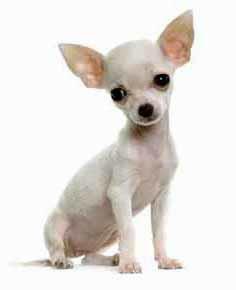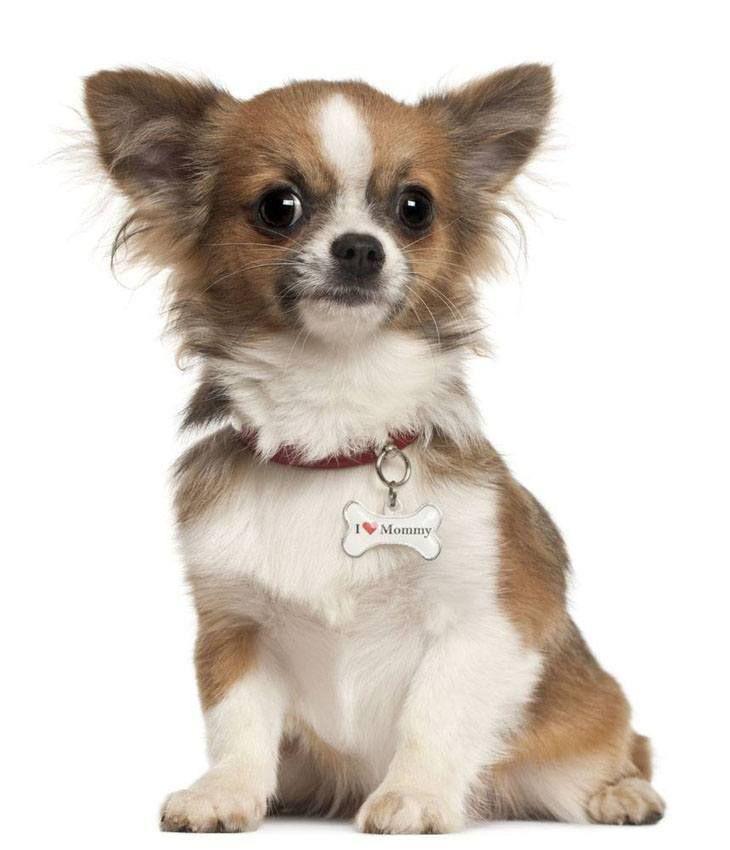The first image is the image on the left, the second image is the image on the right. For the images shown, is this caption "Of the two dogs shown, one dog's ears are floppy or folded, and the other dog's ears are pointy and erect." true? Answer yes or no. No. The first image is the image on the left, the second image is the image on the right. Given the left and right images, does the statement "In the right image, a chihuahua is wearing an object around its neck." hold true? Answer yes or no. Yes. 